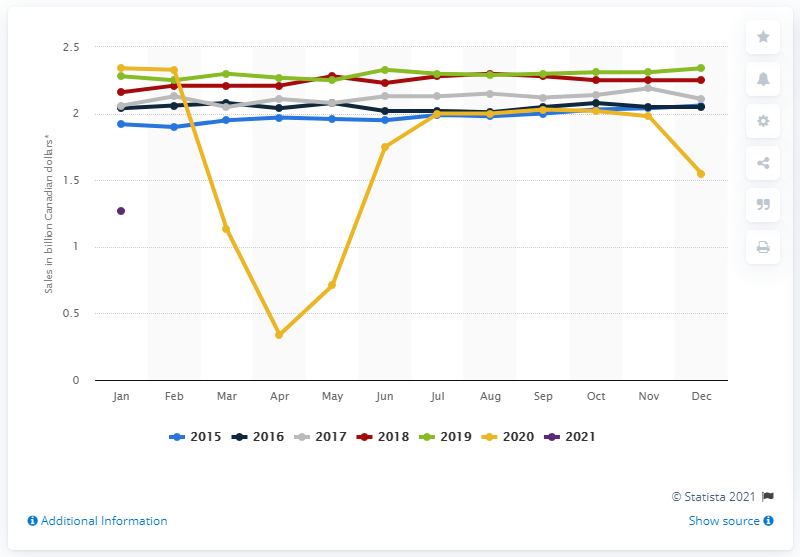Point out several critical features in this image. In January 2021, the retail sales of clothing stores in Canada was 2.34 billion Canadian dollars. In January 2021, the retail sales of clothing stores in Canada totaled 1.27 billion Canadian dollars. 